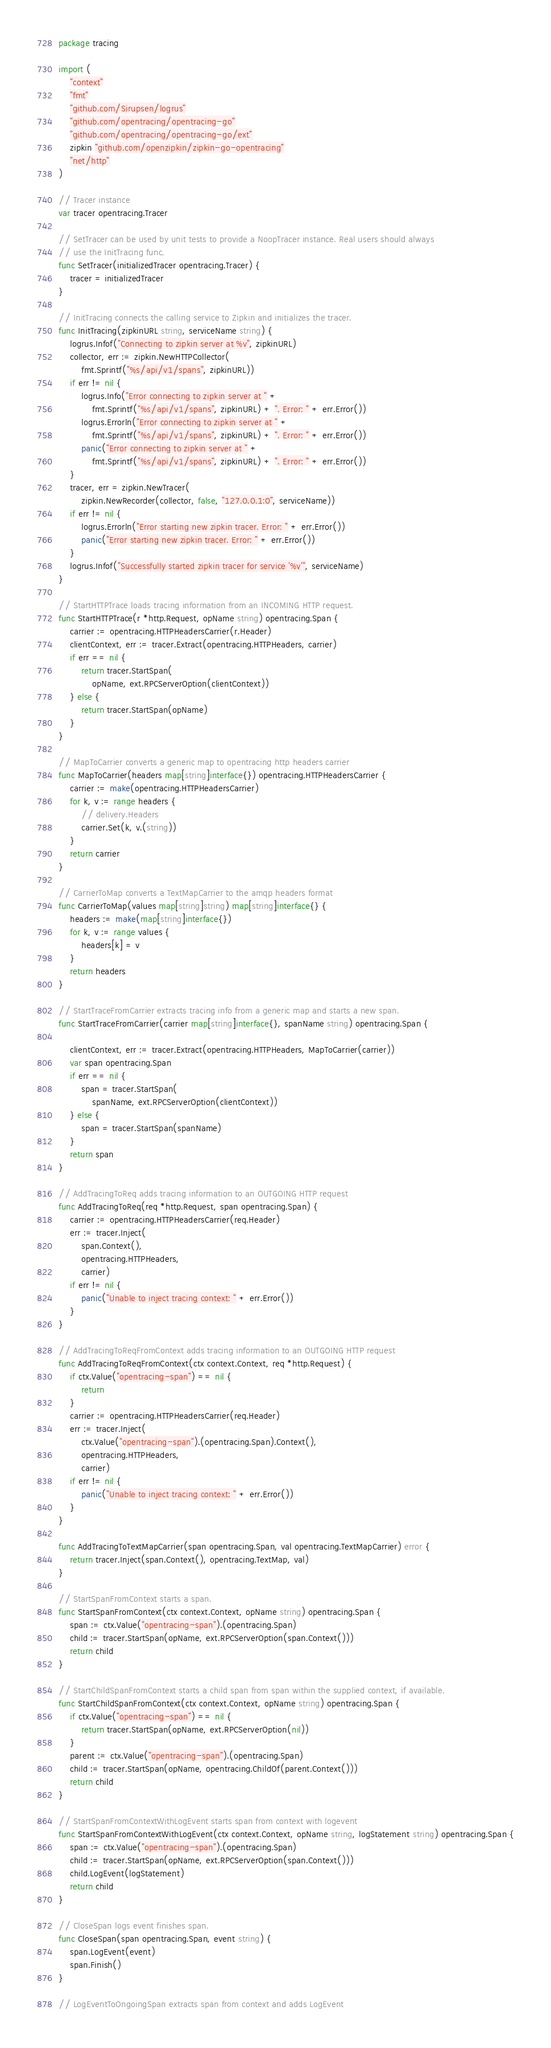Convert code to text. <code><loc_0><loc_0><loc_500><loc_500><_Go_>package tracing

import (
	"context"
	"fmt"
	"github.com/Sirupsen/logrus"
	"github.com/opentracing/opentracing-go"
	"github.com/opentracing/opentracing-go/ext"
	zipkin "github.com/openzipkin/zipkin-go-opentracing"
	"net/http"
)

// Tracer instance
var tracer opentracing.Tracer

// SetTracer can be used by unit tests to provide a NoopTracer instance. Real users should always
// use the InitTracing func.
func SetTracer(initializedTracer opentracing.Tracer) {
	tracer = initializedTracer
}

// InitTracing connects the calling service to Zipkin and initializes the tracer.
func InitTracing(zipkinURL string, serviceName string) {
	logrus.Infof("Connecting to zipkin server at %v", zipkinURL)
	collector, err := zipkin.NewHTTPCollector(
		fmt.Sprintf("%s/api/v1/spans", zipkinURL))
	if err != nil {
		logrus.Info("Error connecting to zipkin server at " +
			fmt.Sprintf("%s/api/v1/spans", zipkinURL) + ". Error: " + err.Error())
		logrus.Errorln("Error connecting to zipkin server at " +
			fmt.Sprintf("%s/api/v1/spans", zipkinURL) + ". Error: " + err.Error())
		panic("Error connecting to zipkin server at " +
			fmt.Sprintf("%s/api/v1/spans", zipkinURL) + ". Error: " + err.Error())
	}
	tracer, err = zipkin.NewTracer(
		zipkin.NewRecorder(collector, false, "127.0.0.1:0", serviceName))
	if err != nil {
		logrus.Errorln("Error starting new zipkin tracer. Error: " + err.Error())
		panic("Error starting new zipkin tracer. Error: " + err.Error())
	}
	logrus.Infof("Successfully started zipkin tracer for service '%v'", serviceName)
}

// StartHTTPTrace loads tracing information from an INCOMING HTTP request.
func StartHTTPTrace(r *http.Request, opName string) opentracing.Span {
	carrier := opentracing.HTTPHeadersCarrier(r.Header)
	clientContext, err := tracer.Extract(opentracing.HTTPHeaders, carrier)
	if err == nil {
		return tracer.StartSpan(
			opName, ext.RPCServerOption(clientContext))
	} else {
		return tracer.StartSpan(opName)
	}
}

// MapToCarrier converts a generic map to opentracing http headers carrier
func MapToCarrier(headers map[string]interface{}) opentracing.HTTPHeadersCarrier {
	carrier := make(opentracing.HTTPHeadersCarrier)
	for k, v := range headers {
		// delivery.Headers
		carrier.Set(k, v.(string))
	}
	return carrier
}

// CarrierToMap converts a TextMapCarrier to the amqp headers format
func CarrierToMap(values map[string]string) map[string]interface{} {
	headers := make(map[string]interface{})
	for k, v := range values {
		headers[k] = v
	}
	return headers
}

// StartTraceFromCarrier extracts tracing info from a generic map and starts a new span.
func StartTraceFromCarrier(carrier map[string]interface{}, spanName string) opentracing.Span {

	clientContext, err := tracer.Extract(opentracing.HTTPHeaders, MapToCarrier(carrier))
	var span opentracing.Span
	if err == nil {
		span = tracer.StartSpan(
			spanName, ext.RPCServerOption(clientContext))
	} else {
		span = tracer.StartSpan(spanName)
	}
	return span
}

// AddTracingToReq adds tracing information to an OUTGOING HTTP request
func AddTracingToReq(req *http.Request, span opentracing.Span) {
	carrier := opentracing.HTTPHeadersCarrier(req.Header)
	err := tracer.Inject(
		span.Context(),
		opentracing.HTTPHeaders,
		carrier)
	if err != nil {
		panic("Unable to inject tracing context: " + err.Error())
	}
}

// AddTracingToReqFromContext adds tracing information to an OUTGOING HTTP request
func AddTracingToReqFromContext(ctx context.Context, req *http.Request) {
	if ctx.Value("opentracing-span") == nil {
		return
	}
	carrier := opentracing.HTTPHeadersCarrier(req.Header)
	err := tracer.Inject(
		ctx.Value("opentracing-span").(opentracing.Span).Context(),
		opentracing.HTTPHeaders,
		carrier)
	if err != nil {
		panic("Unable to inject tracing context: " + err.Error())
	}
}

func AddTracingToTextMapCarrier(span opentracing.Span, val opentracing.TextMapCarrier) error {
	return tracer.Inject(span.Context(), opentracing.TextMap, val)
}

// StartSpanFromContext starts a span.
func StartSpanFromContext(ctx context.Context, opName string) opentracing.Span {
	span := ctx.Value("opentracing-span").(opentracing.Span)
	child := tracer.StartSpan(opName, ext.RPCServerOption(span.Context()))
	return child
}

// StartChildSpanFromContext starts a child span from span within the supplied context, if available.
func StartChildSpanFromContext(ctx context.Context, opName string) opentracing.Span {
	if ctx.Value("opentracing-span") == nil {
		return tracer.StartSpan(opName, ext.RPCServerOption(nil))
	}
	parent := ctx.Value("opentracing-span").(opentracing.Span)
	child := tracer.StartSpan(opName, opentracing.ChildOf(parent.Context()))
	return child
}

// StartSpanFromContextWithLogEvent starts span from context with logevent
func StartSpanFromContextWithLogEvent(ctx context.Context, opName string, logStatement string) opentracing.Span {
	span := ctx.Value("opentracing-span").(opentracing.Span)
	child := tracer.StartSpan(opName, ext.RPCServerOption(span.Context()))
	child.LogEvent(logStatement)
	return child
}

// CloseSpan logs event finishes span.
func CloseSpan(span opentracing.Span, event string) {
	span.LogEvent(event)
	span.Finish()
}

// LogEventToOngoingSpan extracts span from context and adds LogEvent</code> 